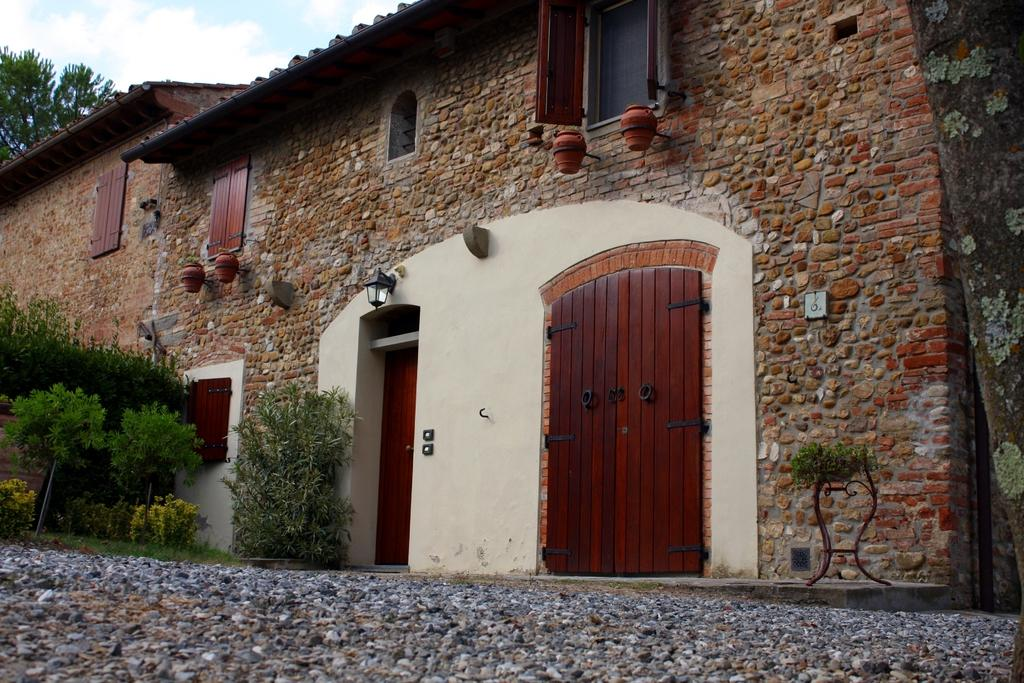What type of structure is in the image? There is a building in the image. What materials are used for the walls of the building? The building has stone and brick walls. What materials are used for the windows and doors of the building? The building has wooden windows and doors. What can be seen on the left side of the image? There are plants on the left side of the image. What is at the bottom of the image? There is a stone way at the bottom of the image. What team is responsible for sorting the rays in the image? There are no rays or teams present in the image; it features a building with stone and brick walls, wooden windows and doors, plants on the left side, and a stone way at the bottom. 